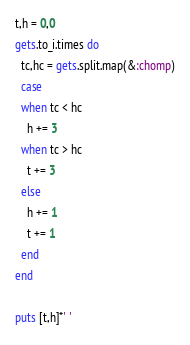<code> <loc_0><loc_0><loc_500><loc_500><_Ruby_>t,h = 0,0
gets.to_i.times do
  tc,hc = gets.split.map(&:chomp)
  case
  when tc < hc
    h += 3
  when tc > hc
    t += 3
  else
    h += 1
    t += 1
  end
end

puts [t,h]*' '</code> 